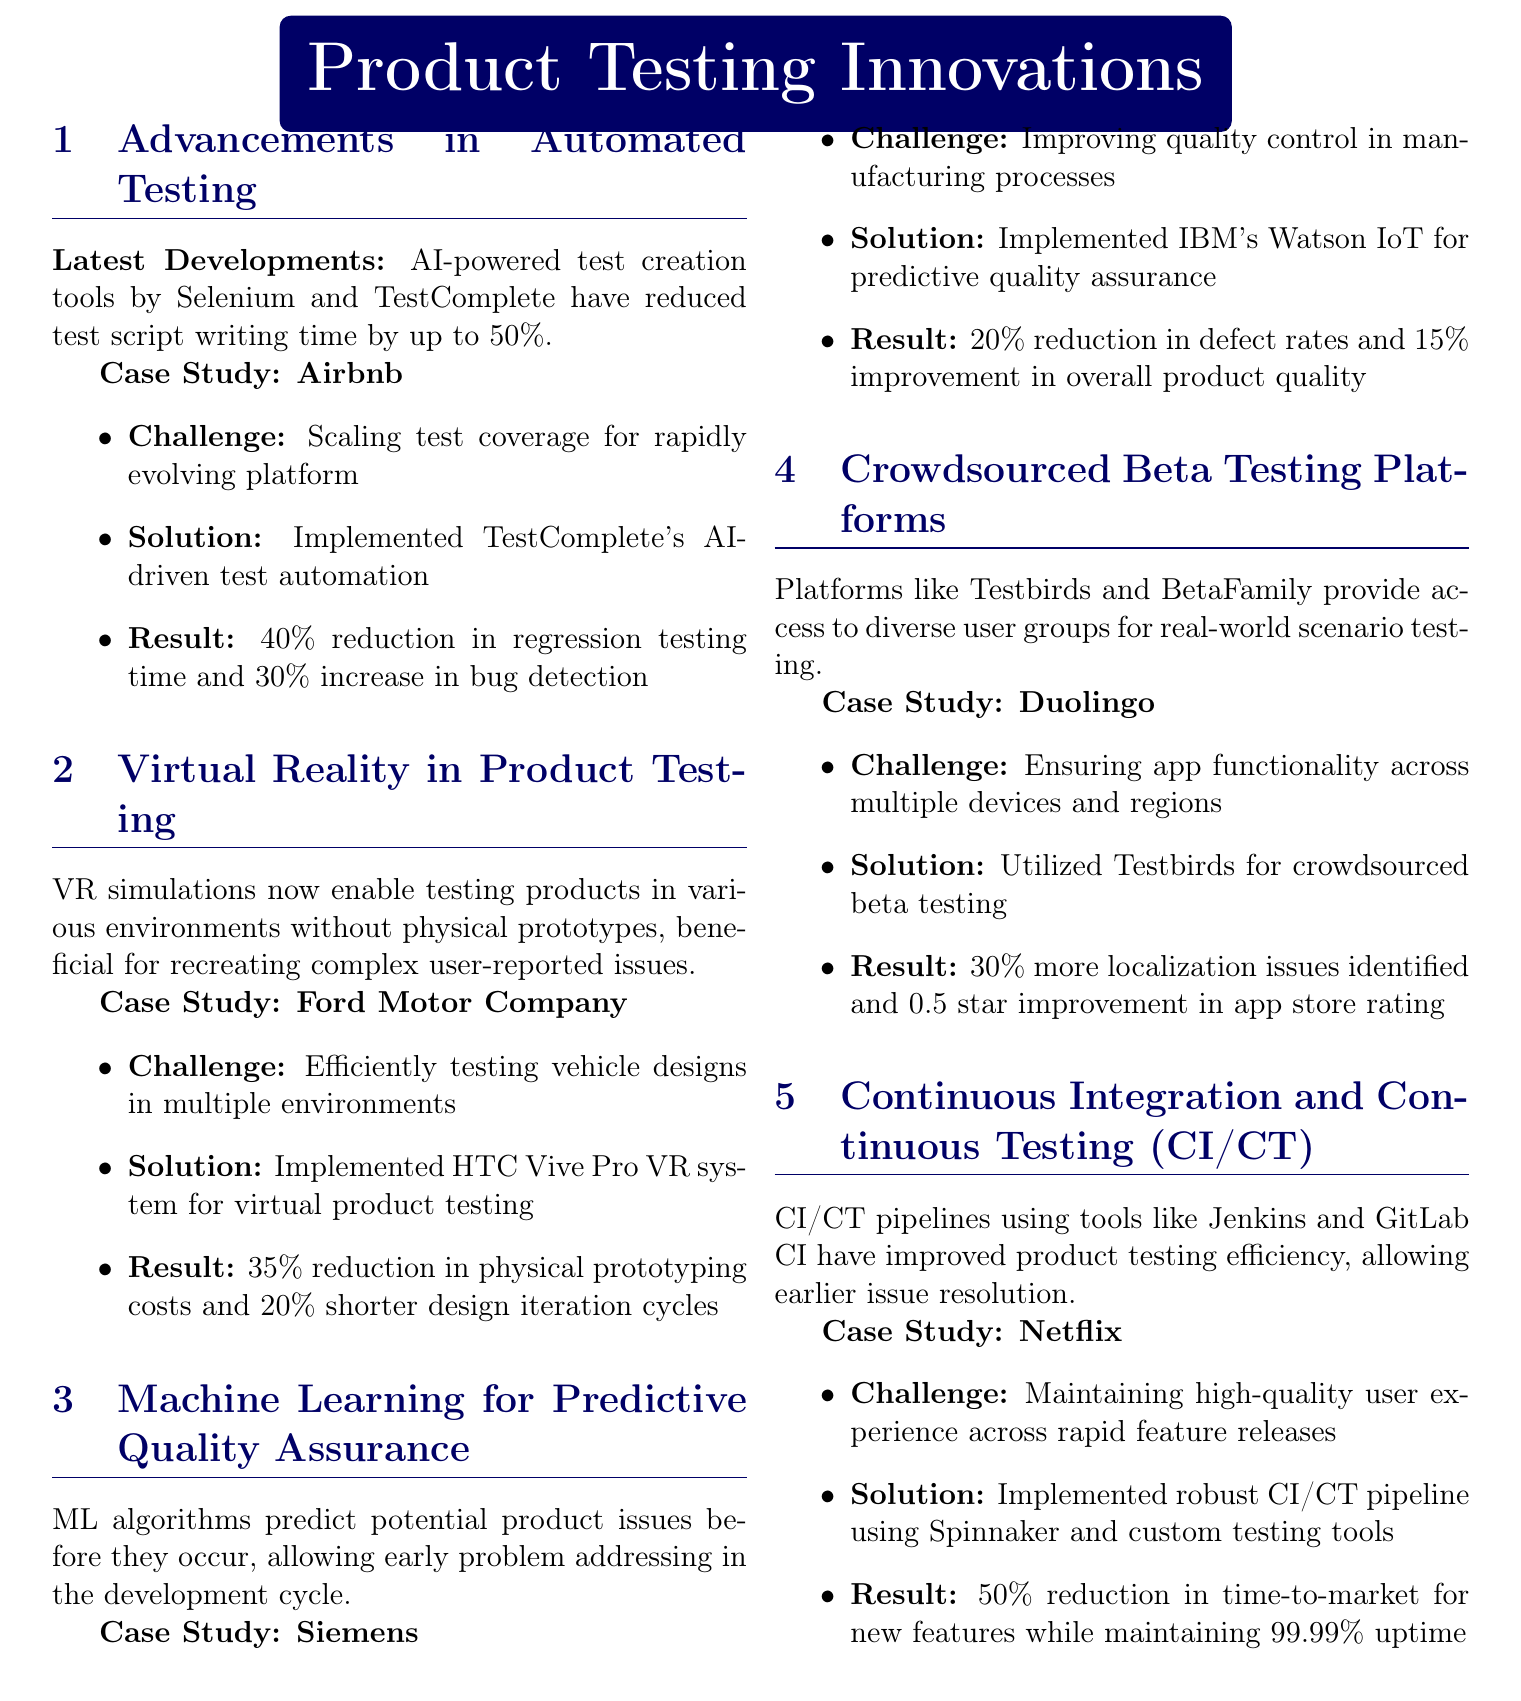What company implemented AI-powered test automation? The document states that Airbnb implemented TestComplete's AI-driven test automation.
Answer: Airbnb What was the result of Ford's VR product testing solution? According to the document, Ford achieved a 35% reduction in physical prototyping costs and a 20% shorter design iteration cycle.
Answer: 35% reduction in physical prototyping costs and 20% shorter design iteration cycles What machine learning tool did Siemens use for predictive quality assurance? The document mentions that Siemens implemented IBM's Watson IoT for predictive quality assurance.
Answer: IBM's Watson IoT What percentage of localization issues did Duolingo identify through crowdsourced beta testing? The document states that Duolingo identified 30% more localization issues using Testbirds for crowdsourced beta testing.
Answer: 30% What challenge was faced by Netflix regarding user experience? The document describes Netflix's challenge as maintaining high-quality user experience across rapid feature releases.
Answer: Maintaining high-quality user experience across rapid feature releases How much did Netflix reduce time-to-market for new features? The document indicates that Netflix reduced the time-to-market for new features by 50%.
Answer: 50% What is a benefit of using CI/CT pipelines mentioned in the document? The document suggests that CI/CT pipelines allow earlier issue resolution, thereby improving product testing efficiency.
Answer: Allow earlier issue resolution What technology did Ford use for virtual product testing? According to the document, Ford implemented the HTC Vive Pro VR system for virtual product testing.
Answer: HTC Vive Pro VR system 